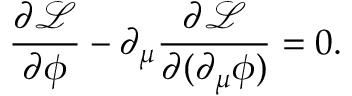<formula> <loc_0><loc_0><loc_500><loc_500>\frac { \partial \mathcal { L } } { \partial \phi } - \partial _ { \mu } \frac { \partial \mathcal { L } } { \partial ( \partial _ { \mu } \phi ) } = 0 .</formula> 